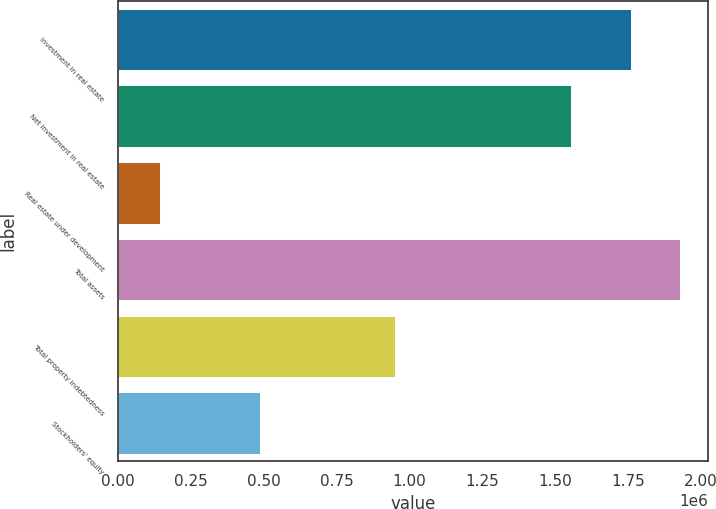Convert chart to OTSL. <chart><loc_0><loc_0><loc_500><loc_500><bar_chart><fcel>Investment in real estate<fcel>Net investment in real estate<fcel>Real estate under development<fcel>Total assets<fcel>Total property indebtedness<fcel>Stockholders' equity<nl><fcel>1.76222e+06<fcel>1.55421e+06<fcel>143818<fcel>1.92847e+06<fcel>949889<fcel>485691<nl></chart> 